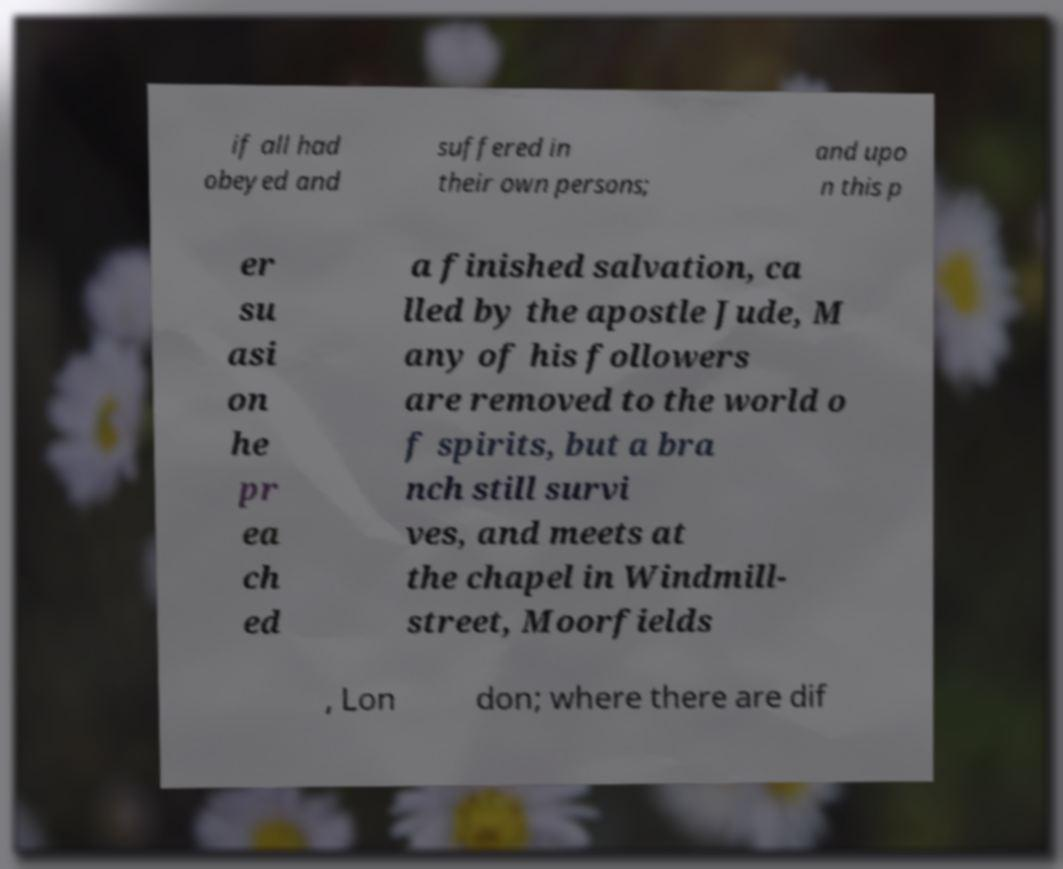Can you read and provide the text displayed in the image?This photo seems to have some interesting text. Can you extract and type it out for me? if all had obeyed and suffered in their own persons; and upo n this p er su asi on he pr ea ch ed a finished salvation, ca lled by the apostle Jude, M any of his followers are removed to the world o f spirits, but a bra nch still survi ves, and meets at the chapel in Windmill- street, Moorfields , Lon don; where there are dif 